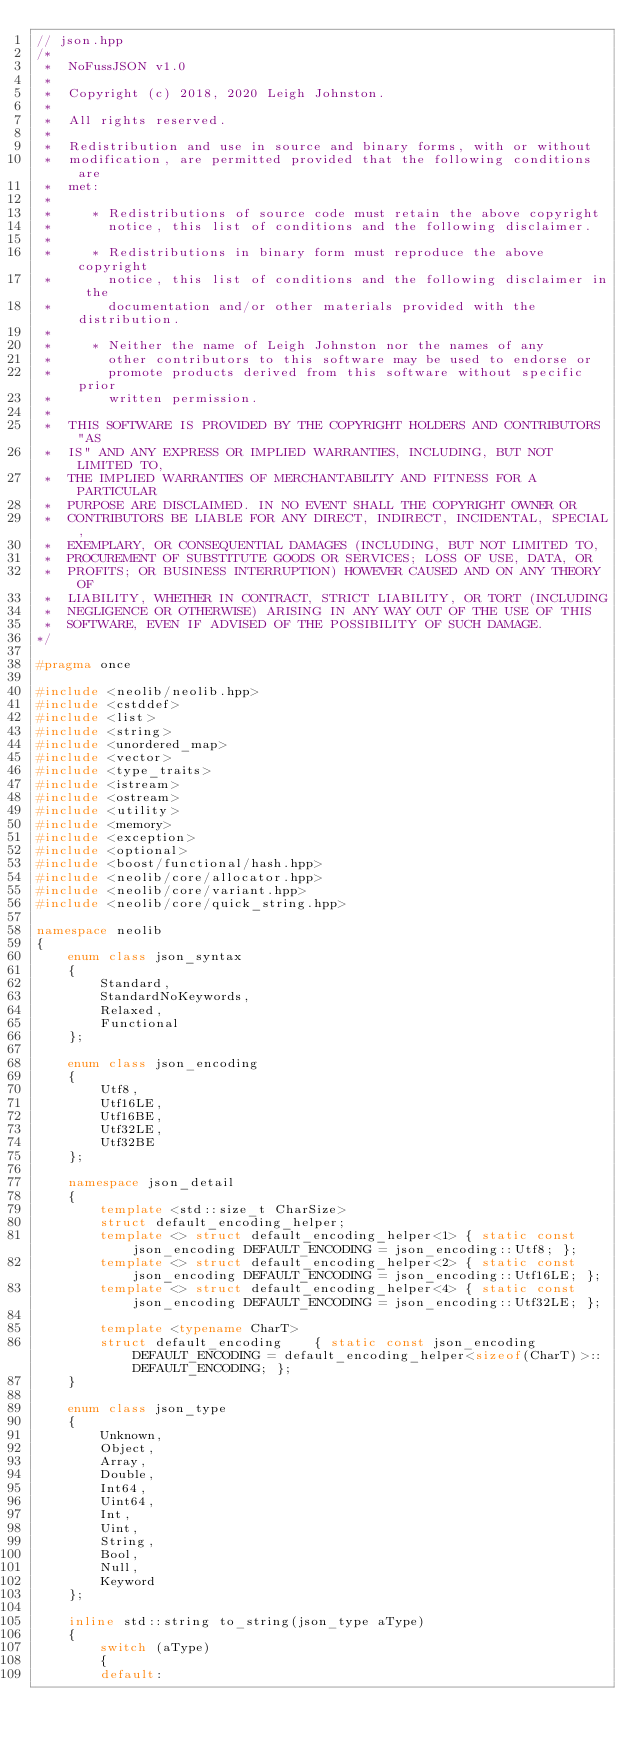<code> <loc_0><loc_0><loc_500><loc_500><_C++_>// json.hpp
/*
 *  NoFussJSON v1.0
 *
 *  Copyright (c) 2018, 2020 Leigh Johnston.
 *
 *  All rights reserved.
 *
 *  Redistribution and use in source and binary forms, with or without
 *  modification, are permitted provided that the following conditions are
 *  met:
 *
 *     * Redistributions of source code must retain the above copyright
 *       notice, this list of conditions and the following disclaimer.
 *
 *     * Redistributions in binary form must reproduce the above copyright
 *       notice, this list of conditions and the following disclaimer in the
 *       documentation and/or other materials provided with the distribution.
 *
 *     * Neither the name of Leigh Johnston nor the names of any
 *       other contributors to this software may be used to endorse or
 *       promote products derived from this software without specific prior
 *       written permission.
 *
 *  THIS SOFTWARE IS PROVIDED BY THE COPYRIGHT HOLDERS AND CONTRIBUTORS "AS
 *  IS" AND ANY EXPRESS OR IMPLIED WARRANTIES, INCLUDING, BUT NOT LIMITED TO,
 *  THE IMPLIED WARRANTIES OF MERCHANTABILITY AND FITNESS FOR A PARTICULAR
 *  PURPOSE ARE DISCLAIMED. IN NO EVENT SHALL THE COPYRIGHT OWNER OR
 *  CONTRIBUTORS BE LIABLE FOR ANY DIRECT, INDIRECT, INCIDENTAL, SPECIAL,
 *  EXEMPLARY, OR CONSEQUENTIAL DAMAGES (INCLUDING, BUT NOT LIMITED TO,
 *  PROCUREMENT OF SUBSTITUTE GOODS OR SERVICES; LOSS OF USE, DATA, OR
 *  PROFITS; OR BUSINESS INTERRUPTION) HOWEVER CAUSED AND ON ANY THEORY OF
 *  LIABILITY, WHETHER IN CONTRACT, STRICT LIABILITY, OR TORT (INCLUDING
 *  NEGLIGENCE OR OTHERWISE) ARISING IN ANY WAY OUT OF THE USE OF THIS
 *  SOFTWARE, EVEN IF ADVISED OF THE POSSIBILITY OF SUCH DAMAGE.
*/

#pragma once

#include <neolib/neolib.hpp>
#include <cstddef>
#include <list>
#include <string>
#include <unordered_map>
#include <vector>
#include <type_traits>
#include <istream>
#include <ostream>
#include <utility>
#include <memory>
#include <exception>
#include <optional>
#include <boost/functional/hash.hpp>
#include <neolib/core/allocator.hpp>
#include <neolib/core/variant.hpp>
#include <neolib/core/quick_string.hpp>

namespace neolib
{
    enum class json_syntax
    {
        Standard,
        StandardNoKeywords,
        Relaxed,
        Functional
    };

    enum class json_encoding
    {
        Utf8,
        Utf16LE,
        Utf16BE,
        Utf32LE,
        Utf32BE
    };

    namespace json_detail
    {
        template <std::size_t CharSize>
        struct default_encoding_helper;
        template <> struct default_encoding_helper<1> { static const json_encoding DEFAULT_ENCODING = json_encoding::Utf8; };
        template <> struct default_encoding_helper<2> { static const json_encoding DEFAULT_ENCODING = json_encoding::Utf16LE; };
        template <> struct default_encoding_helper<4> { static const json_encoding DEFAULT_ENCODING = json_encoding::Utf32LE; };

        template <typename CharT>
        struct default_encoding    { static const json_encoding DEFAULT_ENCODING = default_encoding_helper<sizeof(CharT)>::DEFAULT_ENCODING; };
    }

    enum class json_type
    {
        Unknown,
        Object,
        Array,
        Double,
        Int64,
        Uint64,
        Int,
        Uint,
        String,
        Bool,
        Null,
        Keyword
    };

    inline std::string to_string(json_type aType)
    {
        switch (aType)
        {
        default:</code> 